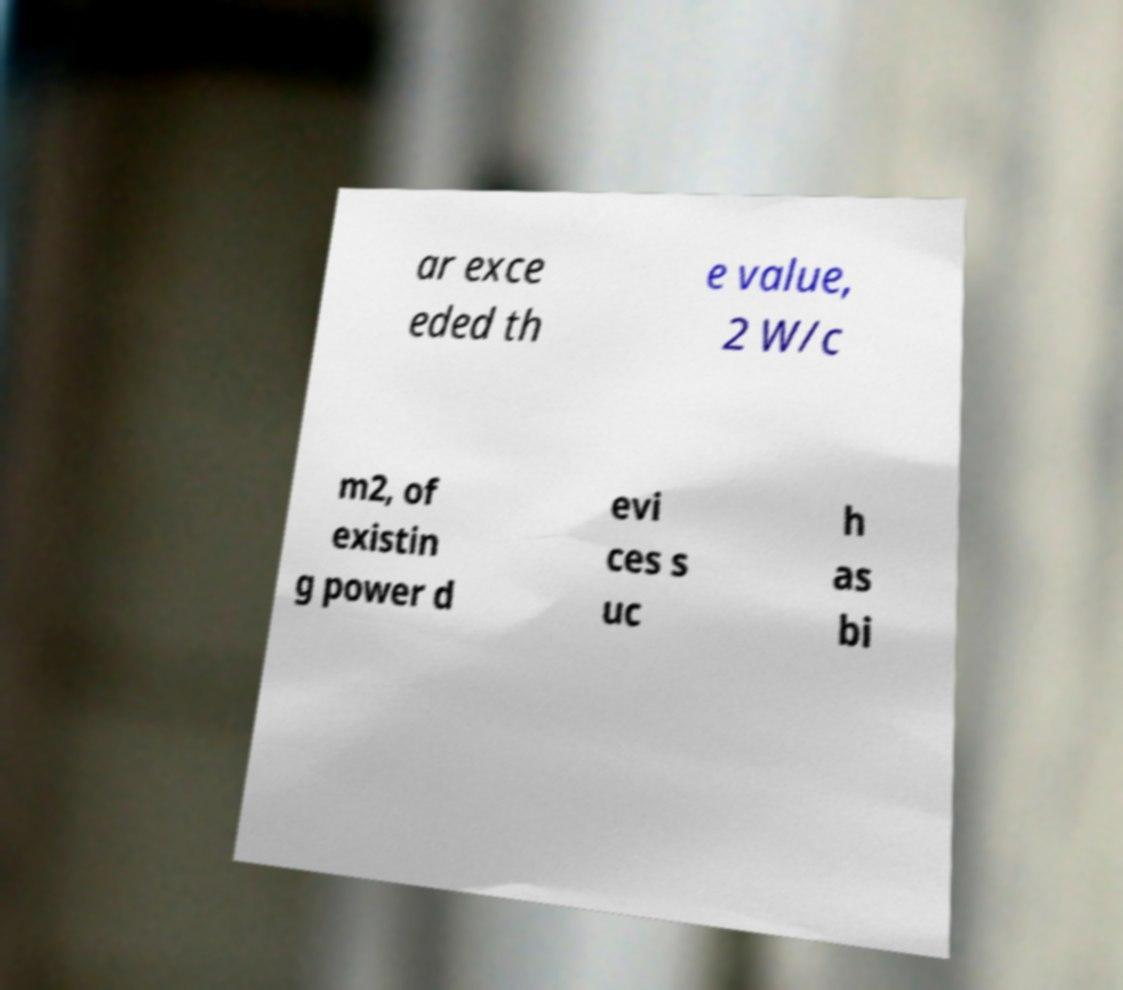Please identify and transcribe the text found in this image. ar exce eded th e value, 2 W/c m2, of existin g power d evi ces s uc h as bi 